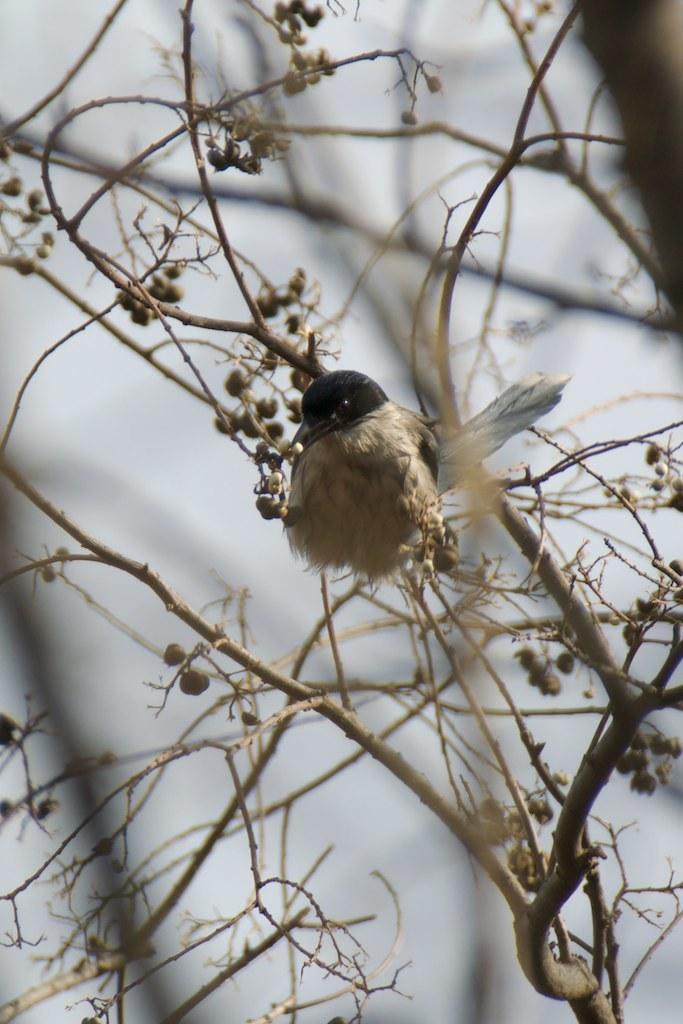Describe this image in one or two sentences. In this picture there is a bird on the tree and there might be fruits on the tree. At the back the image is blurry. 